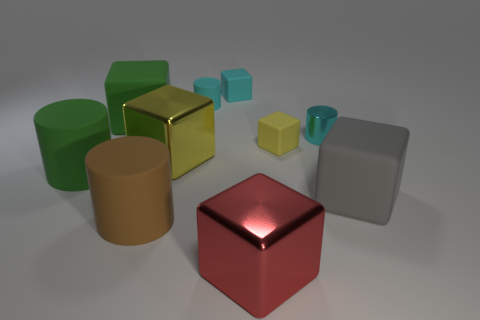How is the lighting affecting the appearance of the objects? The lighting in the image casts soft shadows and highlights on the objects, emphasizing their three-dimensional forms and the differences in their surfaces. The metallic objects are more reflective, therefore they catch light and produce sharp highlights, while the rubber blocks have diffused and softer shadows. 